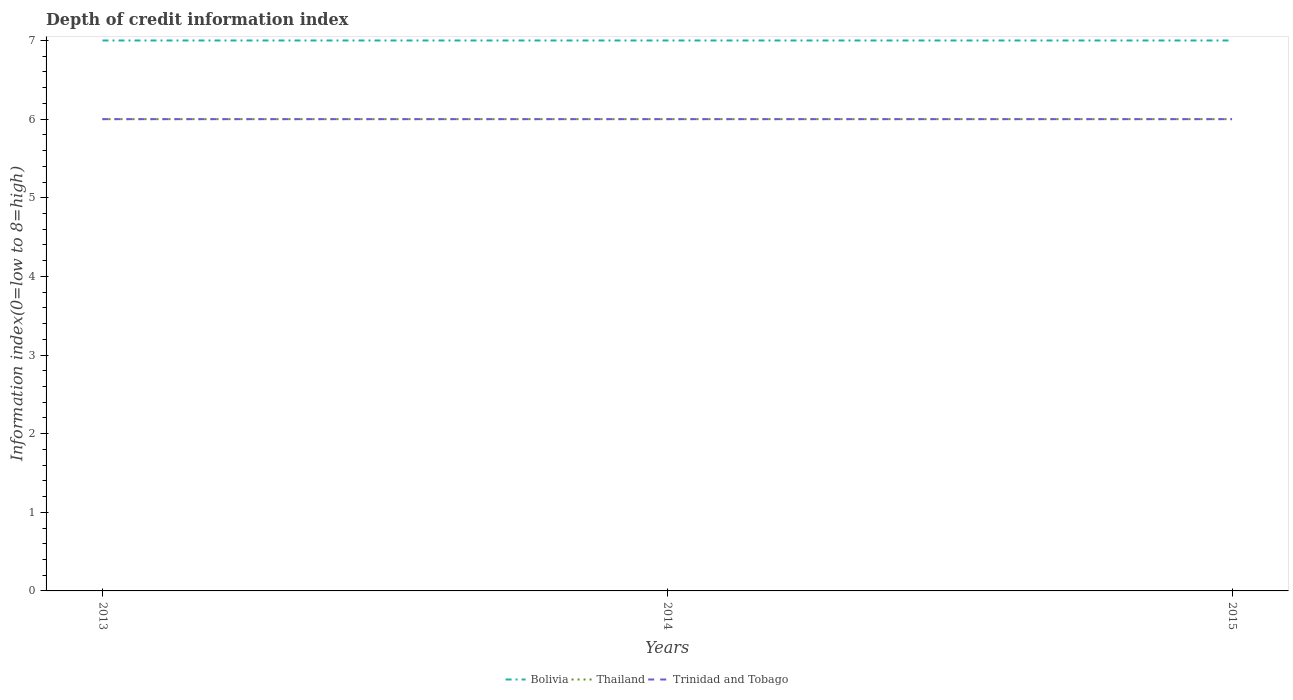How many different coloured lines are there?
Offer a very short reply. 3. Does the line corresponding to Bolivia intersect with the line corresponding to Trinidad and Tobago?
Offer a terse response. No. Is the number of lines equal to the number of legend labels?
Ensure brevity in your answer.  Yes. Across all years, what is the maximum information index in Trinidad and Tobago?
Provide a short and direct response. 6. What is the difference between the highest and the second highest information index in Thailand?
Your answer should be compact. 0. What is the difference between the highest and the lowest information index in Thailand?
Provide a succinct answer. 0. Is the information index in Thailand strictly greater than the information index in Bolivia over the years?
Ensure brevity in your answer.  Yes. How many years are there in the graph?
Provide a short and direct response. 3. What is the difference between two consecutive major ticks on the Y-axis?
Your answer should be compact. 1. Does the graph contain any zero values?
Provide a succinct answer. No. How many legend labels are there?
Keep it short and to the point. 3. How are the legend labels stacked?
Ensure brevity in your answer.  Horizontal. What is the title of the graph?
Give a very brief answer. Depth of credit information index. What is the label or title of the X-axis?
Ensure brevity in your answer.  Years. What is the label or title of the Y-axis?
Offer a terse response. Information index(0=low to 8=high). What is the Information index(0=low to 8=high) in Bolivia in 2013?
Offer a terse response. 7. What is the Information index(0=low to 8=high) of Thailand in 2013?
Ensure brevity in your answer.  6. What is the Information index(0=low to 8=high) of Bolivia in 2015?
Your answer should be compact. 7. What is the Information index(0=low to 8=high) in Trinidad and Tobago in 2015?
Offer a terse response. 6. Across all years, what is the minimum Information index(0=low to 8=high) of Trinidad and Tobago?
Give a very brief answer. 6. What is the total Information index(0=low to 8=high) of Thailand in the graph?
Give a very brief answer. 18. What is the total Information index(0=low to 8=high) in Trinidad and Tobago in the graph?
Give a very brief answer. 18. What is the difference between the Information index(0=low to 8=high) in Thailand in 2013 and that in 2015?
Ensure brevity in your answer.  0. What is the difference between the Information index(0=low to 8=high) of Bolivia in 2013 and the Information index(0=low to 8=high) of Thailand in 2014?
Your response must be concise. 1. What is the difference between the Information index(0=low to 8=high) of Bolivia in 2013 and the Information index(0=low to 8=high) of Trinidad and Tobago in 2014?
Provide a short and direct response. 1. What is the difference between the Information index(0=low to 8=high) of Thailand in 2013 and the Information index(0=low to 8=high) of Trinidad and Tobago in 2014?
Your response must be concise. 0. What is the difference between the Information index(0=low to 8=high) in Bolivia in 2013 and the Information index(0=low to 8=high) in Thailand in 2015?
Make the answer very short. 1. What is the difference between the Information index(0=low to 8=high) in Bolivia in 2013 and the Information index(0=low to 8=high) in Trinidad and Tobago in 2015?
Offer a terse response. 1. What is the difference between the Information index(0=low to 8=high) in Bolivia in 2014 and the Information index(0=low to 8=high) in Thailand in 2015?
Provide a short and direct response. 1. What is the difference between the Information index(0=low to 8=high) of Bolivia in 2014 and the Information index(0=low to 8=high) of Trinidad and Tobago in 2015?
Your answer should be very brief. 1. What is the average Information index(0=low to 8=high) in Bolivia per year?
Your answer should be compact. 7. What is the average Information index(0=low to 8=high) in Thailand per year?
Keep it short and to the point. 6. In the year 2013, what is the difference between the Information index(0=low to 8=high) of Bolivia and Information index(0=low to 8=high) of Thailand?
Provide a short and direct response. 1. In the year 2013, what is the difference between the Information index(0=low to 8=high) in Bolivia and Information index(0=low to 8=high) in Trinidad and Tobago?
Provide a succinct answer. 1. In the year 2015, what is the difference between the Information index(0=low to 8=high) in Bolivia and Information index(0=low to 8=high) in Thailand?
Make the answer very short. 1. What is the ratio of the Information index(0=low to 8=high) in Thailand in 2013 to that in 2014?
Offer a very short reply. 1. What is the ratio of the Information index(0=low to 8=high) of Trinidad and Tobago in 2013 to that in 2014?
Your answer should be very brief. 1. What is the ratio of the Information index(0=low to 8=high) of Trinidad and Tobago in 2013 to that in 2015?
Offer a terse response. 1. What is the ratio of the Information index(0=low to 8=high) in Thailand in 2014 to that in 2015?
Offer a terse response. 1. What is the ratio of the Information index(0=low to 8=high) of Trinidad and Tobago in 2014 to that in 2015?
Ensure brevity in your answer.  1. What is the difference between the highest and the second highest Information index(0=low to 8=high) in Thailand?
Provide a succinct answer. 0. What is the difference between the highest and the second highest Information index(0=low to 8=high) of Trinidad and Tobago?
Provide a succinct answer. 0. What is the difference between the highest and the lowest Information index(0=low to 8=high) of Bolivia?
Offer a terse response. 0. What is the difference between the highest and the lowest Information index(0=low to 8=high) of Trinidad and Tobago?
Give a very brief answer. 0. 